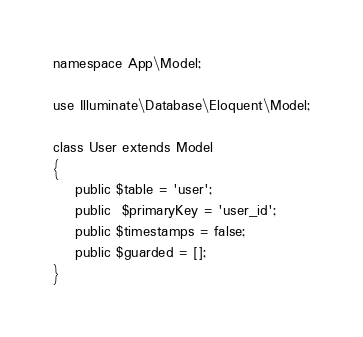<code> <loc_0><loc_0><loc_500><loc_500><_PHP_>
namespace App\Model;

use Illuminate\Database\Eloquent\Model;

class User extends Model
{
    public $table = 'user';
    public  $primaryKey = 'user_id';
    public $timestamps = false;
    public $guarded = [];
}
</code> 